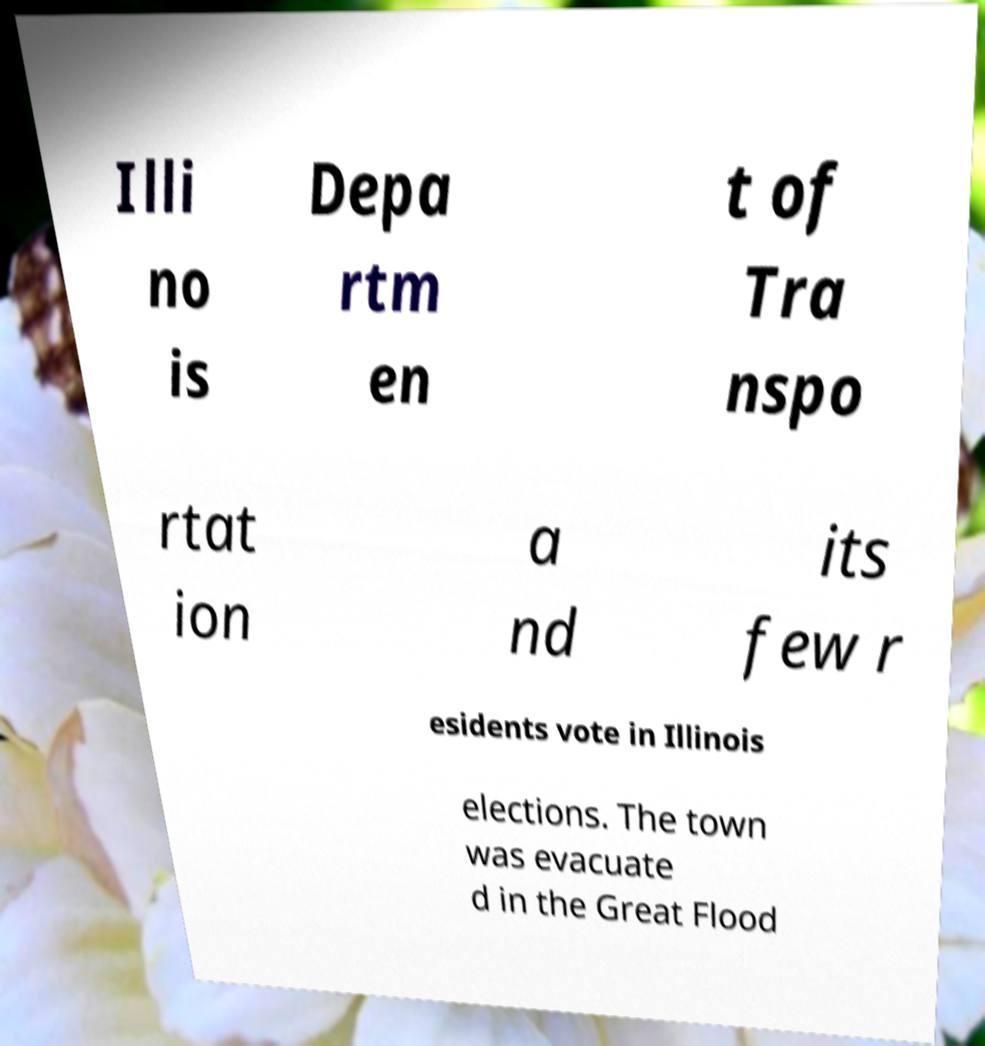What messages or text are displayed in this image? I need them in a readable, typed format. Illi no is Depa rtm en t of Tra nspo rtat ion a nd its few r esidents vote in Illinois elections. The town was evacuate d in the Great Flood 